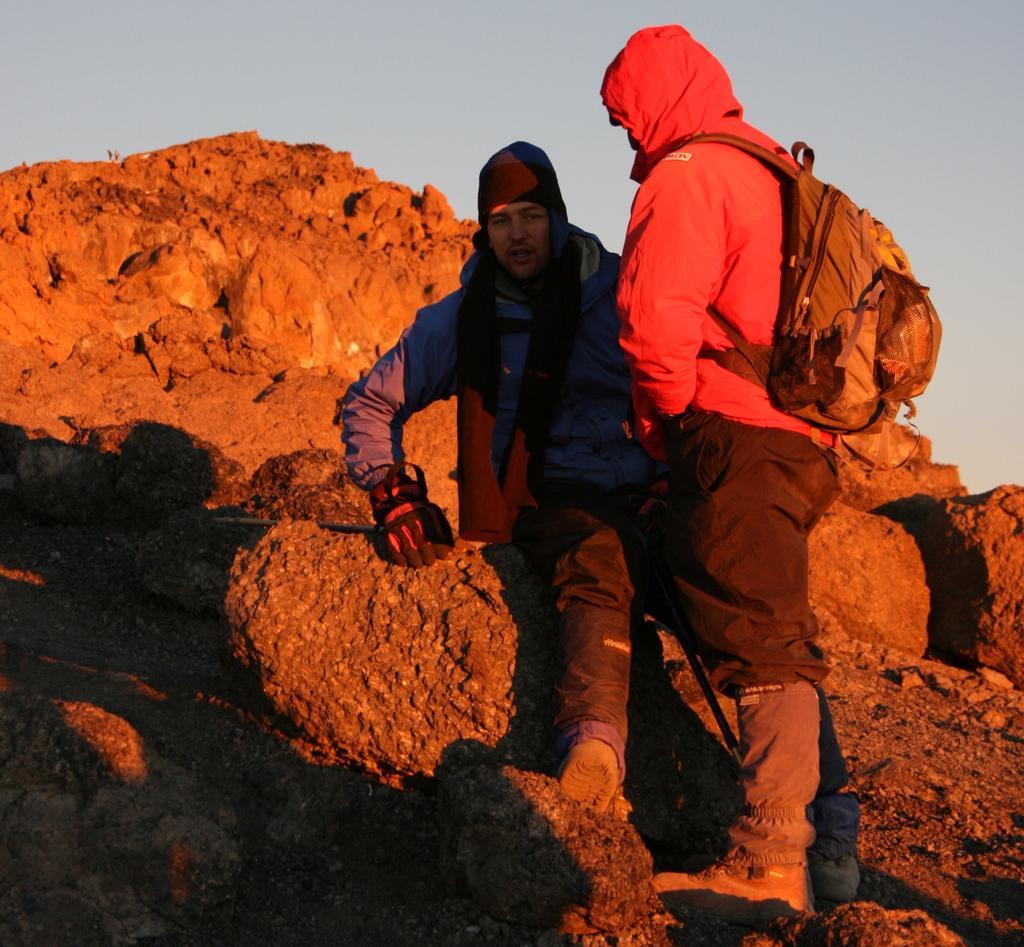Please provide a concise description of this image. In this image I can see the hill , on the hill I can see two persons and one person wearing a backpack ,at the top I can see the sky. 